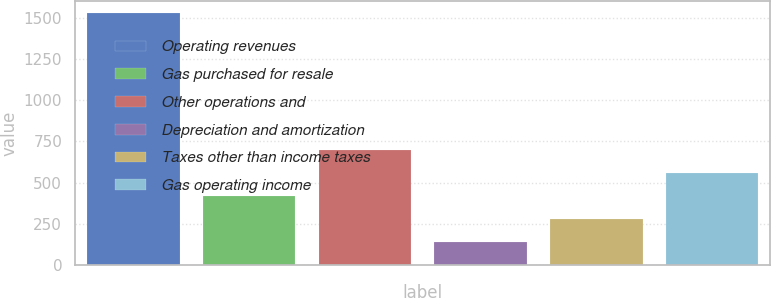Convert chart to OTSL. <chart><loc_0><loc_0><loc_500><loc_500><bar_chart><fcel>Operating revenues<fcel>Gas purchased for resale<fcel>Other operations and<fcel>Depreciation and amortization<fcel>Taxes other than income taxes<fcel>Gas operating income<nl><fcel>1527<fcel>419<fcel>696<fcel>142<fcel>280.5<fcel>557.5<nl></chart> 